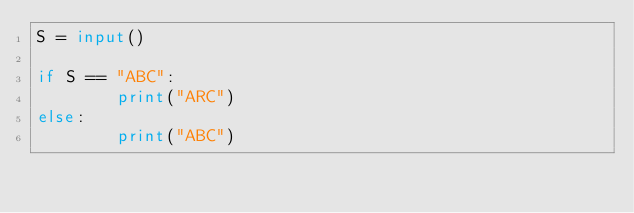Convert code to text. <code><loc_0><loc_0><loc_500><loc_500><_Python_>S = input()

if S == "ABC":
        print("ARC")
else:
        print("ABC")</code> 